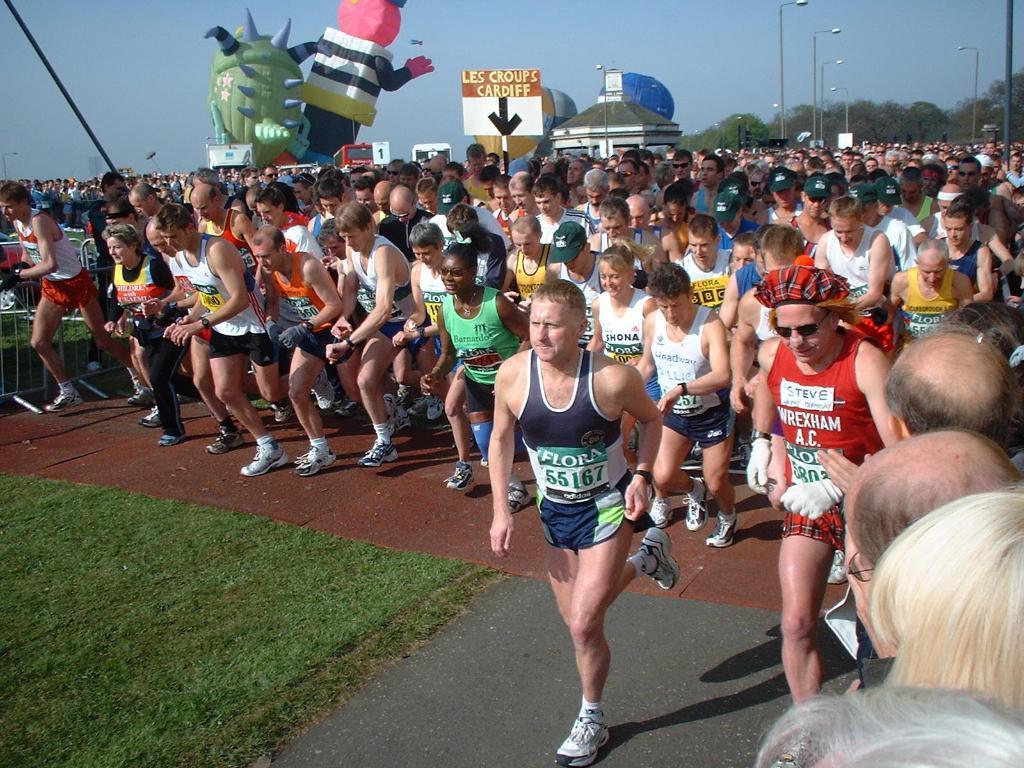In one or two sentences, can you explain what this image depicts? In the image we can see there are people standing on the road and they are running. Behind there are air balloons and the ground is covered with grass. 